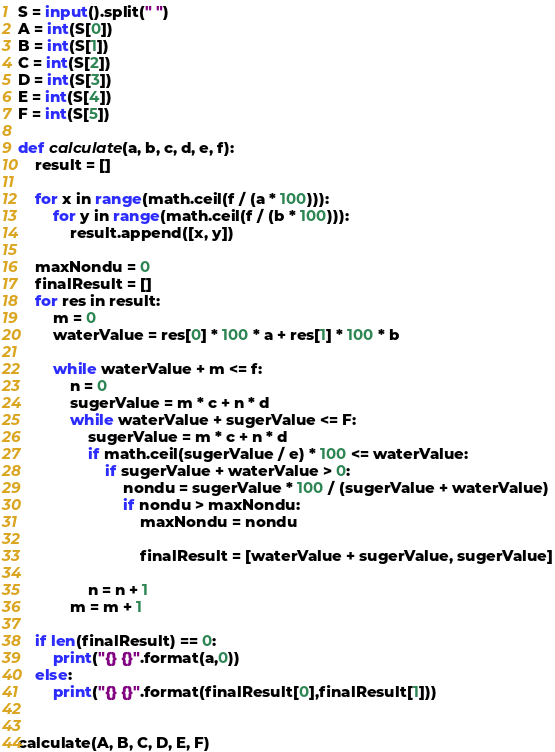Convert code to text. <code><loc_0><loc_0><loc_500><loc_500><_Python_>S = input().split(" ")
A = int(S[0])
B = int(S[1])
C = int(S[2])
D = int(S[3])
E = int(S[4])
F = int(S[5])

def calculate(a, b, c, d, e, f):
    result = []

    for x in range(math.ceil(f / (a * 100))):
        for y in range(math.ceil(f / (b * 100))):
            result.append([x, y])

    maxNondu = 0
    finalResult = []
    for res in result:
        m = 0
        waterValue = res[0] * 100 * a + res[1] * 100 * b

        while waterValue + m <= f:
            n = 0
            sugerValue = m * c + n * d
            while waterValue + sugerValue <= F:
                sugerValue = m * c + n * d
                if math.ceil(sugerValue / e) * 100 <= waterValue:
                    if sugerValue + waterValue > 0:
                        nondu = sugerValue * 100 / (sugerValue + waterValue)
                        if nondu > maxNondu:
                            maxNondu = nondu

                            finalResult = [waterValue + sugerValue, sugerValue]

                n = n + 1
            m = m + 1

    if len(finalResult) == 0:
        print("{} {}".format(a,0))
    else:
        print("{} {}".format(finalResult[0],finalResult[1]))


calculate(A, B, C, D, E, F)</code> 